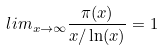<formula> <loc_0><loc_0><loc_500><loc_500>l i m _ { x \rightarrow \infty } \frac { \pi ( x ) } { x / \ln ( x ) } = 1</formula> 